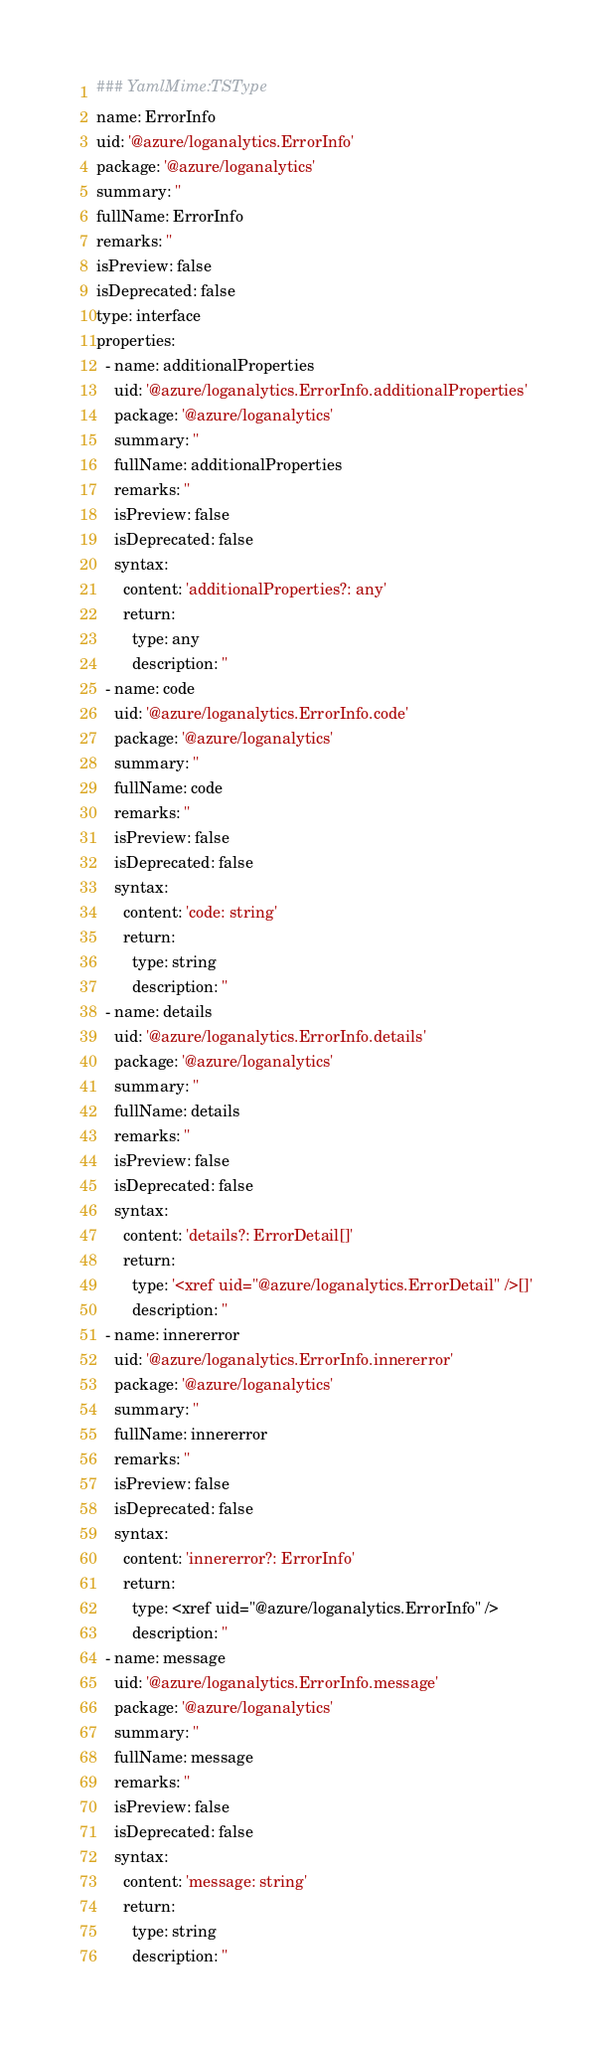<code> <loc_0><loc_0><loc_500><loc_500><_YAML_>### YamlMime:TSType
name: ErrorInfo
uid: '@azure/loganalytics.ErrorInfo'
package: '@azure/loganalytics'
summary: ''
fullName: ErrorInfo
remarks: ''
isPreview: false
isDeprecated: false
type: interface
properties:
  - name: additionalProperties
    uid: '@azure/loganalytics.ErrorInfo.additionalProperties'
    package: '@azure/loganalytics'
    summary: ''
    fullName: additionalProperties
    remarks: ''
    isPreview: false
    isDeprecated: false
    syntax:
      content: 'additionalProperties?: any'
      return:
        type: any
        description: ''
  - name: code
    uid: '@azure/loganalytics.ErrorInfo.code'
    package: '@azure/loganalytics'
    summary: ''
    fullName: code
    remarks: ''
    isPreview: false
    isDeprecated: false
    syntax:
      content: 'code: string'
      return:
        type: string
        description: ''
  - name: details
    uid: '@azure/loganalytics.ErrorInfo.details'
    package: '@azure/loganalytics'
    summary: ''
    fullName: details
    remarks: ''
    isPreview: false
    isDeprecated: false
    syntax:
      content: 'details?: ErrorDetail[]'
      return:
        type: '<xref uid="@azure/loganalytics.ErrorDetail" />[]'
        description: ''
  - name: innererror
    uid: '@azure/loganalytics.ErrorInfo.innererror'
    package: '@azure/loganalytics'
    summary: ''
    fullName: innererror
    remarks: ''
    isPreview: false
    isDeprecated: false
    syntax:
      content: 'innererror?: ErrorInfo'
      return:
        type: <xref uid="@azure/loganalytics.ErrorInfo" />
        description: ''
  - name: message
    uid: '@azure/loganalytics.ErrorInfo.message'
    package: '@azure/loganalytics'
    summary: ''
    fullName: message
    remarks: ''
    isPreview: false
    isDeprecated: false
    syntax:
      content: 'message: string'
      return:
        type: string
        description: ''
</code> 